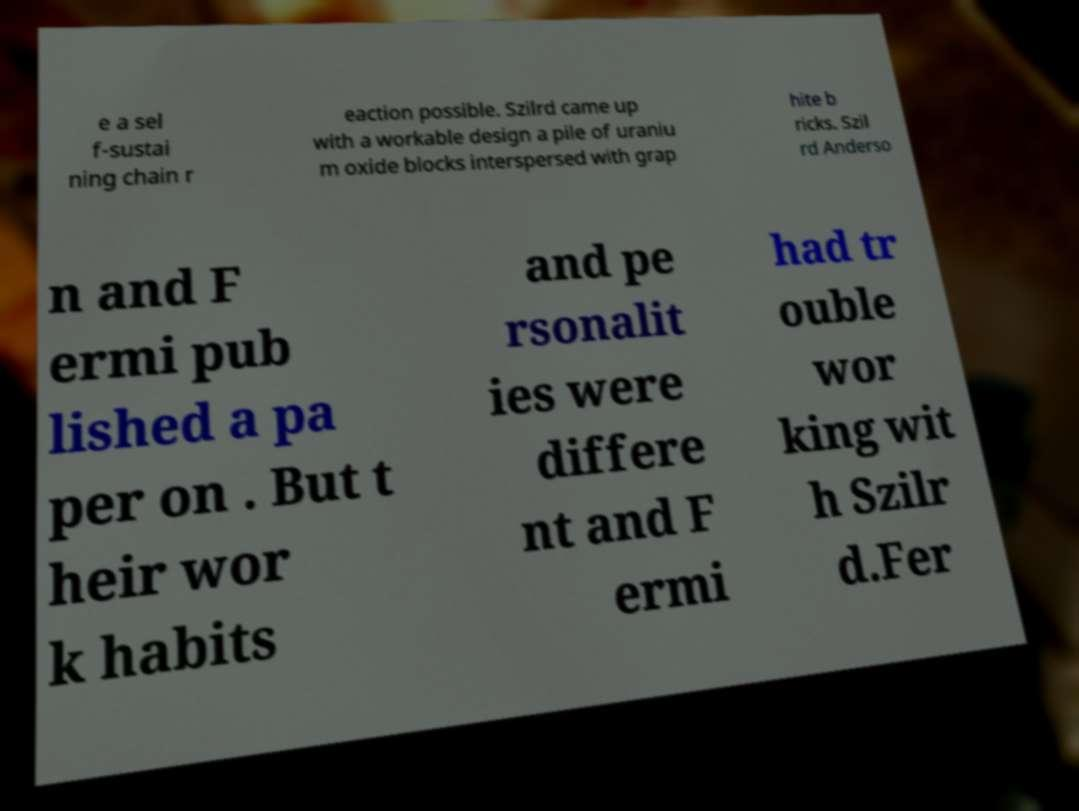What messages or text are displayed in this image? I need them in a readable, typed format. e a sel f-sustai ning chain r eaction possible. Szilrd came up with a workable design a pile of uraniu m oxide blocks interspersed with grap hite b ricks. Szil rd Anderso n and F ermi pub lished a pa per on . But t heir wor k habits and pe rsonalit ies were differe nt and F ermi had tr ouble wor king wit h Szilr d.Fer 